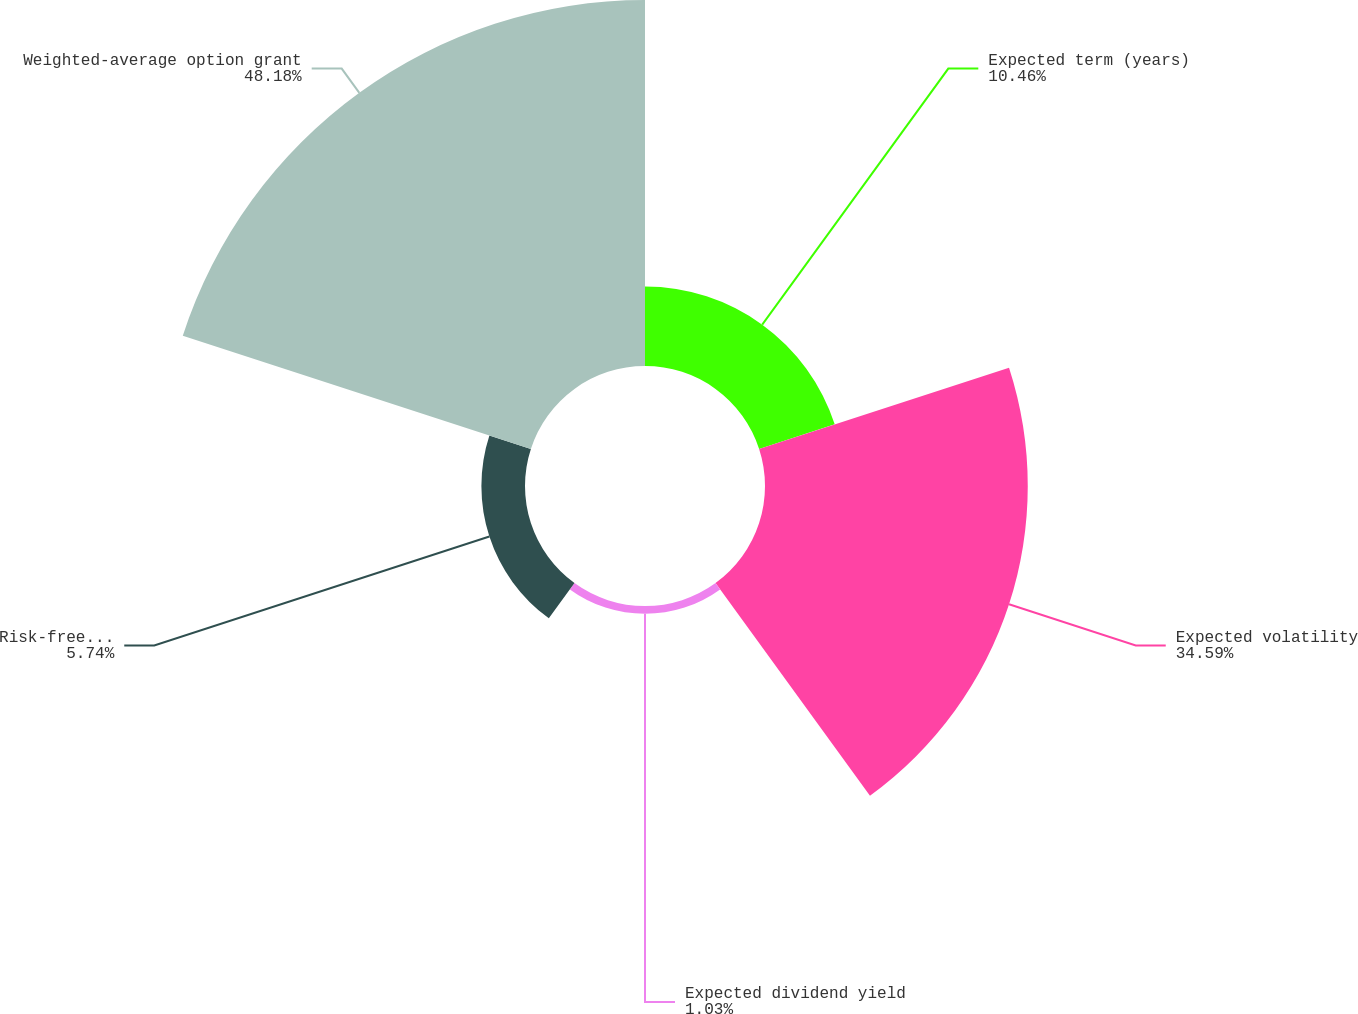Convert chart. <chart><loc_0><loc_0><loc_500><loc_500><pie_chart><fcel>Expected term (years)<fcel>Expected volatility<fcel>Expected dividend yield<fcel>Risk-free interest rate<fcel>Weighted-average option grant<nl><fcel>10.46%<fcel>34.59%<fcel>1.03%<fcel>5.74%<fcel>48.18%<nl></chart> 